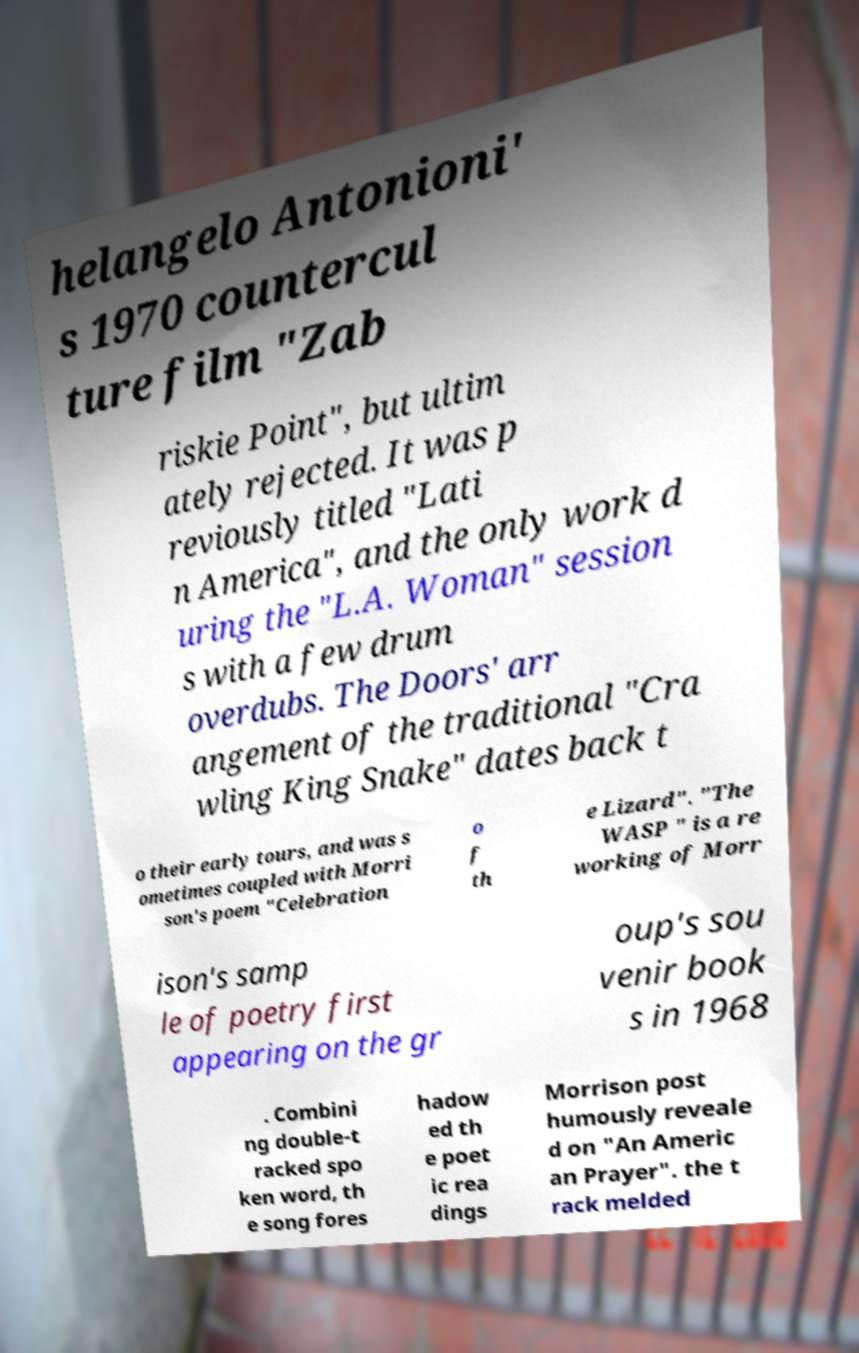Can you accurately transcribe the text from the provided image for me? helangelo Antonioni' s 1970 countercul ture film "Zab riskie Point", but ultim ately rejected. It was p reviously titled "Lati n America", and the only work d uring the "L.A. Woman" session s with a few drum overdubs. The Doors' arr angement of the traditional "Cra wling King Snake" dates back t o their early tours, and was s ometimes coupled with Morri son's poem "Celebration o f th e Lizard". "The WASP " is a re working of Morr ison's samp le of poetry first appearing on the gr oup's sou venir book s in 1968 . Combini ng double-t racked spo ken word, th e song fores hadow ed th e poet ic rea dings Morrison post humously reveale d on "An Americ an Prayer". the t rack melded 